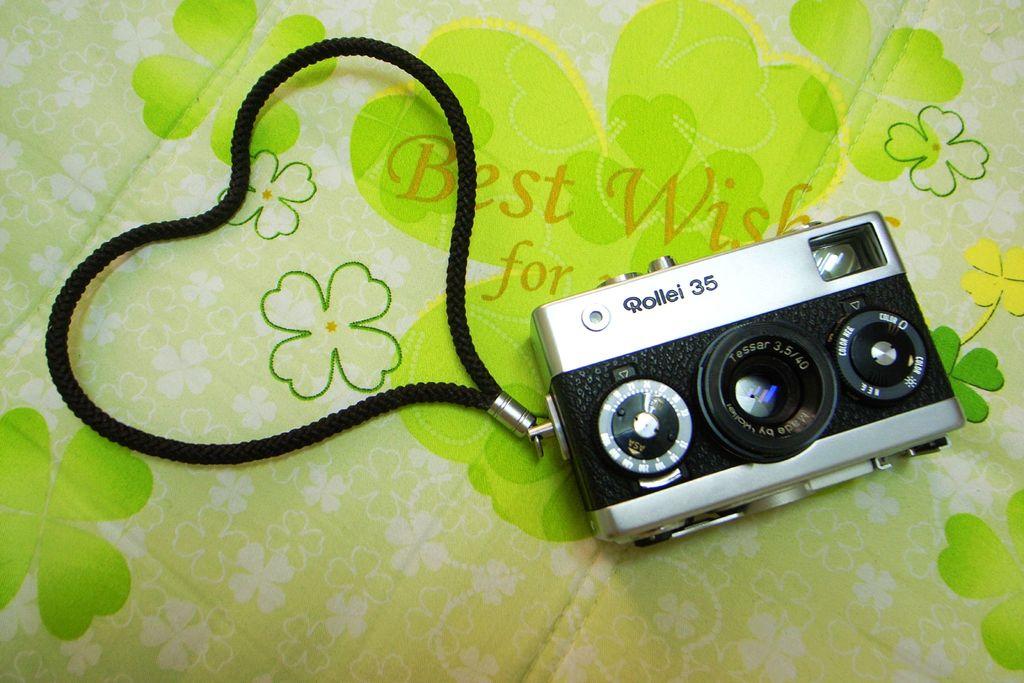What phrase is written on the shamrock?
Offer a very short reply. Best wishes for. 